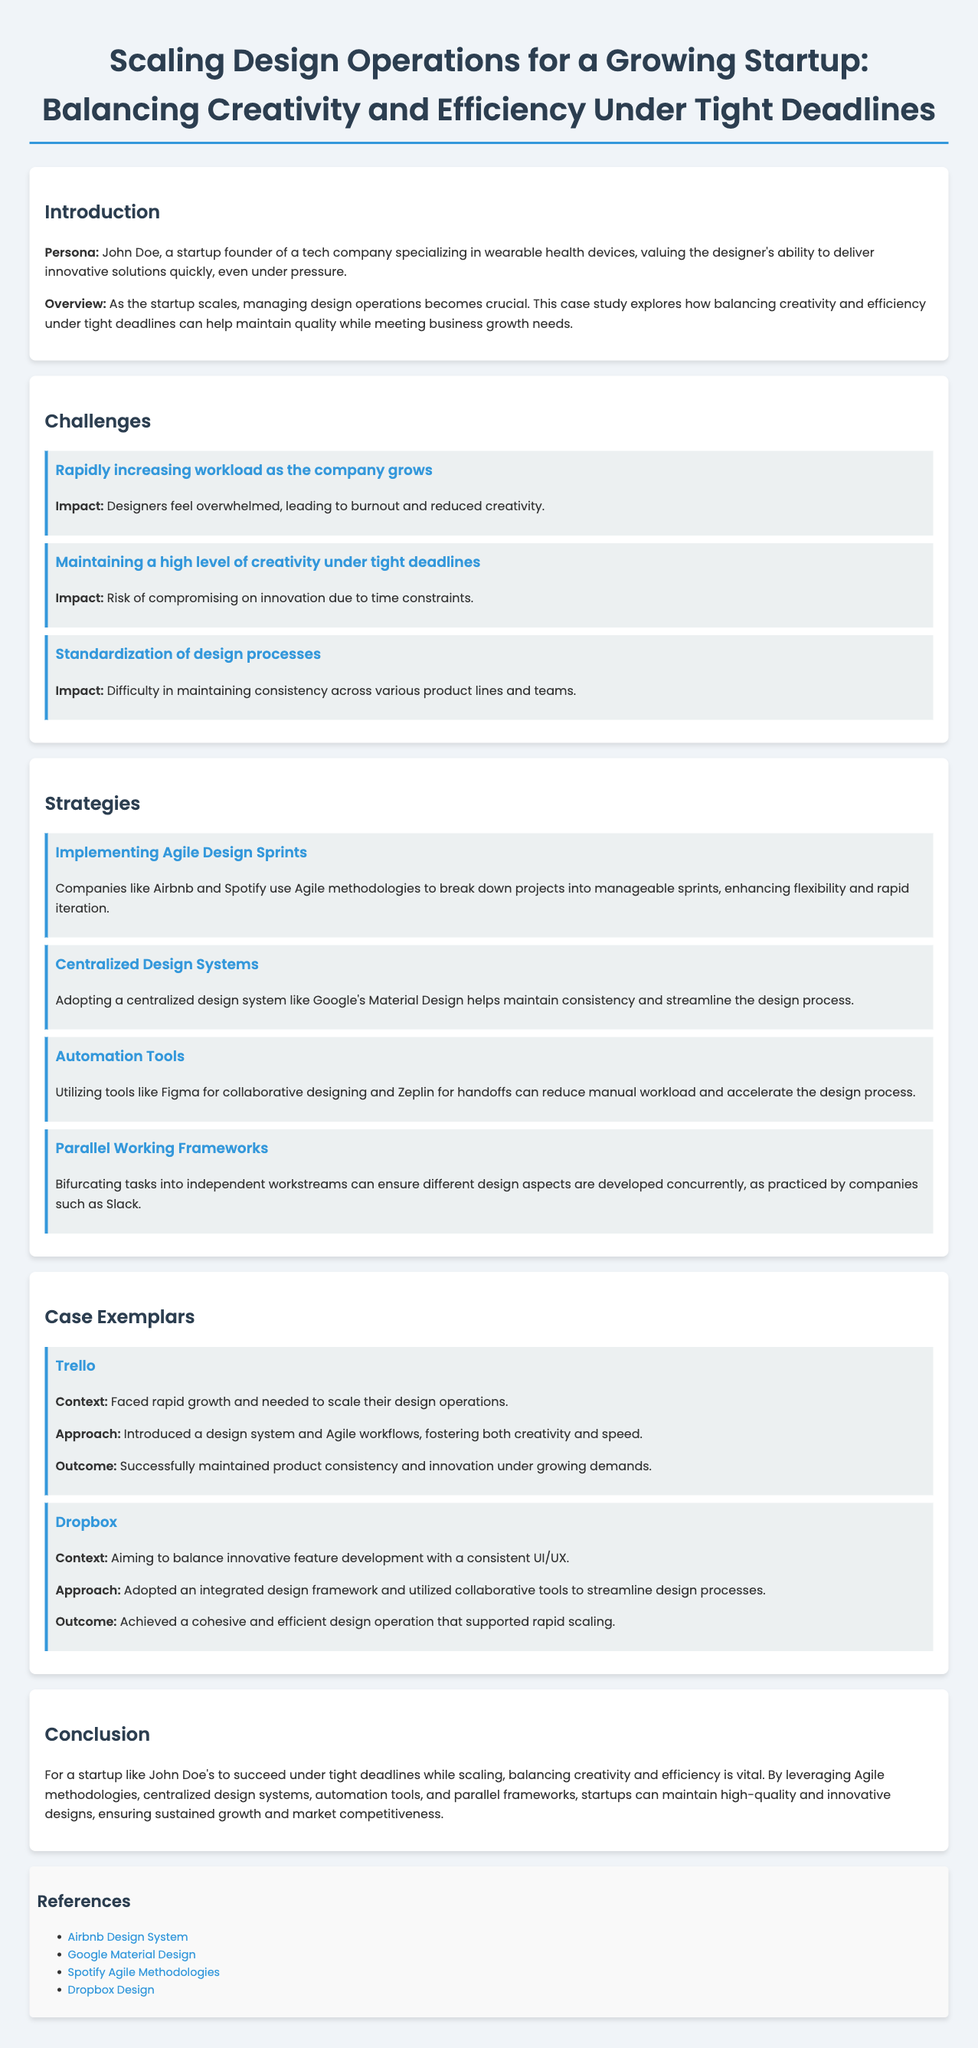What is the main focus of the case study? The case study explores how to balance creativity and efficiency under tight deadlines, which is important as the startup scales.
Answer: Balancing creativity and efficiency Who is the persona in this case study? The persona is mentioned as John Doe, who is a startup founder of a tech company.
Answer: John Doe What is one challenge mentioned that designers face? One specific challenge described is the overwhelming workload due to the company's growth.
Answer: Rapidly increasing workload What is one strategy recommended for design operations? Agile Design Sprints are implemented to enhance flexibility and rapid iteration.
Answer: Implementing Agile Design Sprints Which company used an integrated design framework according to the case exemplars? The exemplar illustrates that Dropbox adopted an integrated design framework.
Answer: Dropbox What is a potential consequence of tight deadlines mentioned in the challenges? The document states that tight deadlines can result in compromising on innovation.
Answer: Compromising on innovation What approach did Trello take to scale their design operations? Trello introduced a design system and Agile workflows to foster both creativity and speed.
Answer: Introduced a design system and Agile workflows Which tool is mentioned as helpful for collaborative designing? Figma is cited as a tool that reduces manual workload and accelerates the design process.
Answer: Figma What is the desired outcome of balancing creativity and efficiency for startups? The outcome is ensuring sustained growth and market competitiveness.
Answer: Sustained growth and market competitiveness 